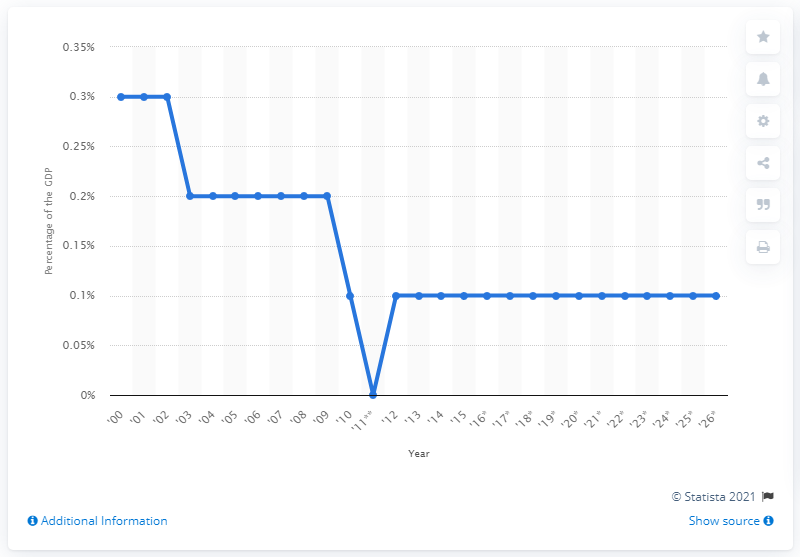Identify some key points in this picture. Estate and gift tax revenues constitute approximately 0.1% of the total United States Gross Domestic Product. 